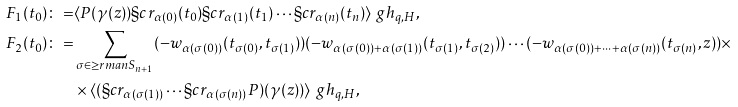Convert formula to latex. <formula><loc_0><loc_0><loc_500><loc_500>F _ { 1 } ( t _ { 0 } ) \colon = & \langle P ( \gamma ( z ) ) \S c r _ { \alpha ( 0 ) } ( t _ { 0 } ) \S c r _ { \alpha ( 1 ) } ( t _ { 1 } ) \cdots \S c r _ { \alpha ( n ) } ( t _ { n } ) \rangle ^ { \ } g h _ { q , H } , \\ F _ { 2 } ( t _ { 0 } ) \colon = & \sum _ { \sigma \in \geq r m a n S _ { n + 1 } } ( - w _ { \alpha ( \sigma ( 0 ) ) } ( t _ { \sigma ( 0 ) } , t _ { \sigma ( 1 ) } ) ) ( - w _ { \alpha ( \sigma ( 0 ) ) + \alpha ( \sigma ( 1 ) ) } ( t _ { \sigma ( 1 ) } , t _ { \sigma ( 2 ) } ) ) \cdots ( - w _ { \alpha ( \sigma ( 0 ) ) + \cdots + \alpha ( \sigma ( n ) ) } ( t _ { \sigma ( n ) } , z ) ) \times \\ & \times \langle ( \S c r _ { \alpha ( \sigma ( 1 ) ) } \cdots \S c r _ { \alpha ( \sigma ( n ) ) } P ) ( \gamma ( z ) ) \rangle ^ { \ } g h _ { q , H } ,</formula> 